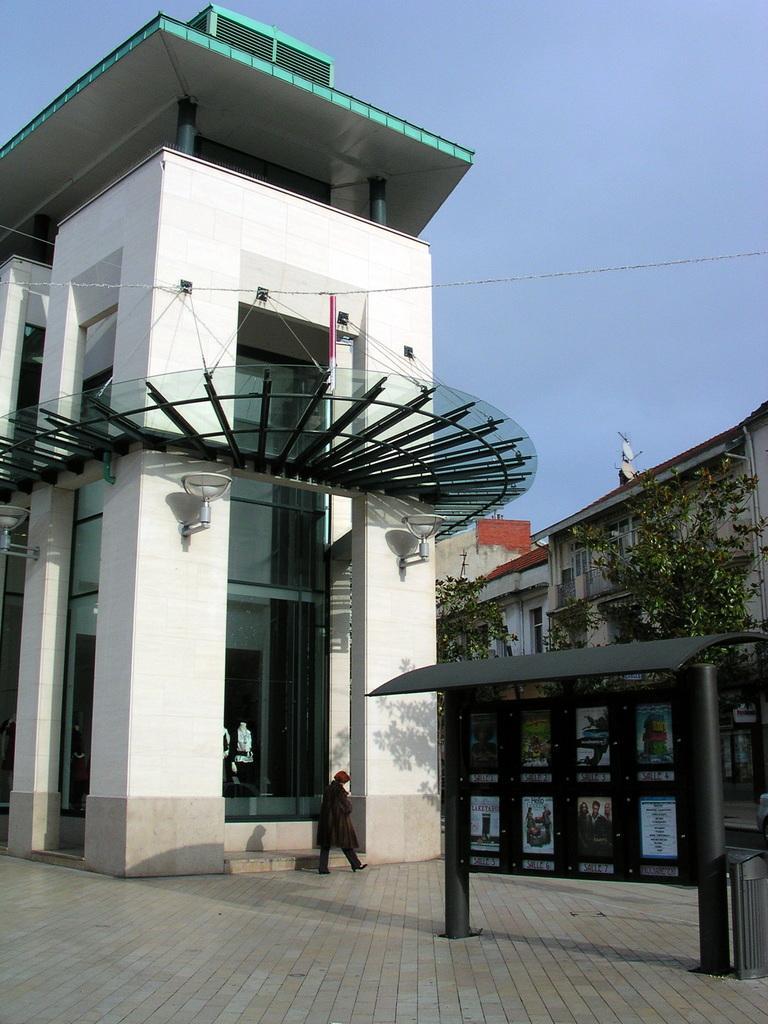How would you summarize this image in a sentence or two? In this image we can see some buildings with windows and street lamps. On the right side we can see a board with some pictures on it. In the center of the image we can see a person walking. On the backside we can see some plants, wires and the sky which looks cloudy. 